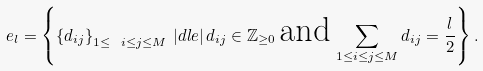Convert formula to latex. <formula><loc_0><loc_0><loc_500><loc_500>e _ { l } = \left \{ \left \{ d _ { i j } \right \} _ { 1 \leq \ i \leq j \leq M } \, | d l e | \, d _ { i j } \in { \mathbb { Z } } _ { \geq 0 } \, \text {and} \, \sum _ { 1 \leq i \leq j \leq M } d _ { i j } = \frac { l } { 2 } \right \} .</formula> 